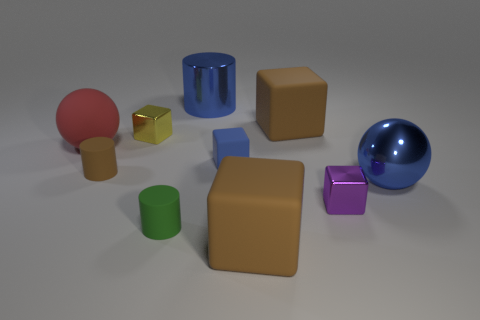Is the large shiny ball the same color as the metal cylinder?
Your answer should be compact. Yes. Is the color of the big metallic object in front of the metal cylinder the same as the metal cylinder?
Provide a short and direct response. Yes. Are there any tiny rubber blocks that have the same color as the large shiny sphere?
Make the answer very short. Yes. There is a big object that is left of the tiny blue matte block and behind the red thing; what color is it?
Your response must be concise. Blue. What is the size of the red rubber object that is on the left side of the big blue cylinder?
Provide a short and direct response. Large. How many green cylinders are the same material as the blue ball?
Ensure brevity in your answer.  0. What shape is the tiny rubber thing that is the same color as the metallic sphere?
Make the answer very short. Cube. Does the tiny purple thing right of the small green object have the same shape as the yellow metal object?
Your response must be concise. Yes. What color is the cylinder that is the same material as the blue sphere?
Make the answer very short. Blue. There is a big shiny object that is on the left side of the brown block that is in front of the metallic sphere; are there any blue cubes that are to the right of it?
Give a very brief answer. Yes. 